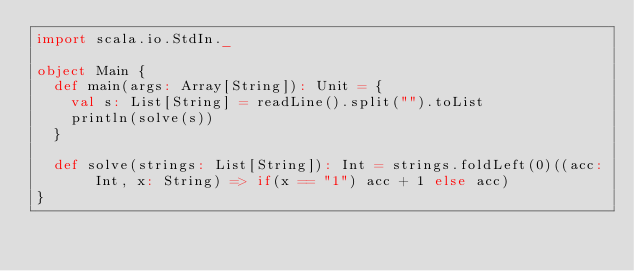Convert code to text. <code><loc_0><loc_0><loc_500><loc_500><_Scala_>import scala.io.StdIn._

object Main {
  def main(args: Array[String]): Unit = {
    val s: List[String] = readLine().split("").toList
    println(solve(s))
  }

  def solve(strings: List[String]): Int = strings.foldLeft(0)((acc: Int, x: String) => if(x == "1") acc + 1 else acc)
}
</code> 